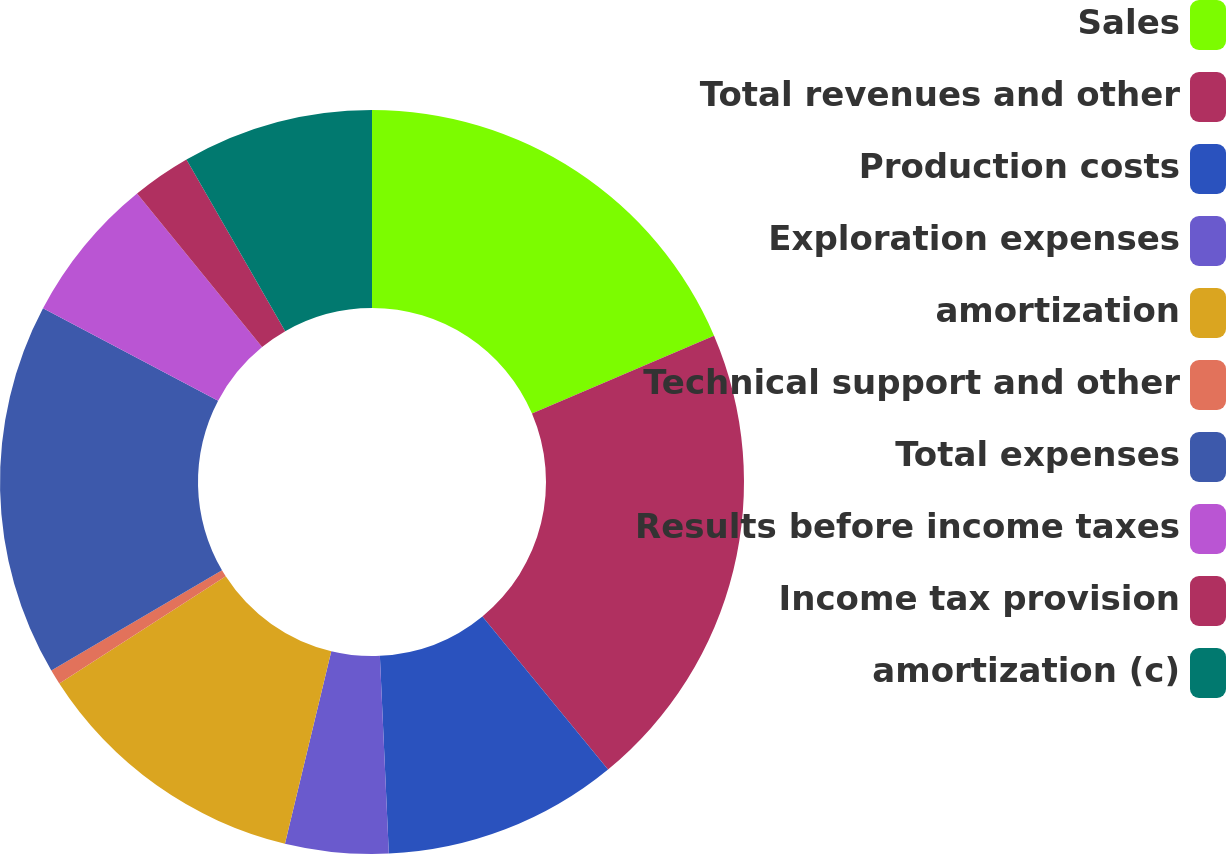<chart> <loc_0><loc_0><loc_500><loc_500><pie_chart><fcel>Sales<fcel>Total revenues and other<fcel>Production costs<fcel>Exploration expenses<fcel>amortization<fcel>Technical support and other<fcel>Total expenses<fcel>Results before income taxes<fcel>Income tax provision<fcel>amortization (c)<nl><fcel>18.57%<fcel>20.49%<fcel>10.22%<fcel>4.48%<fcel>12.13%<fcel>0.65%<fcel>16.19%<fcel>6.39%<fcel>2.57%<fcel>8.31%<nl></chart> 